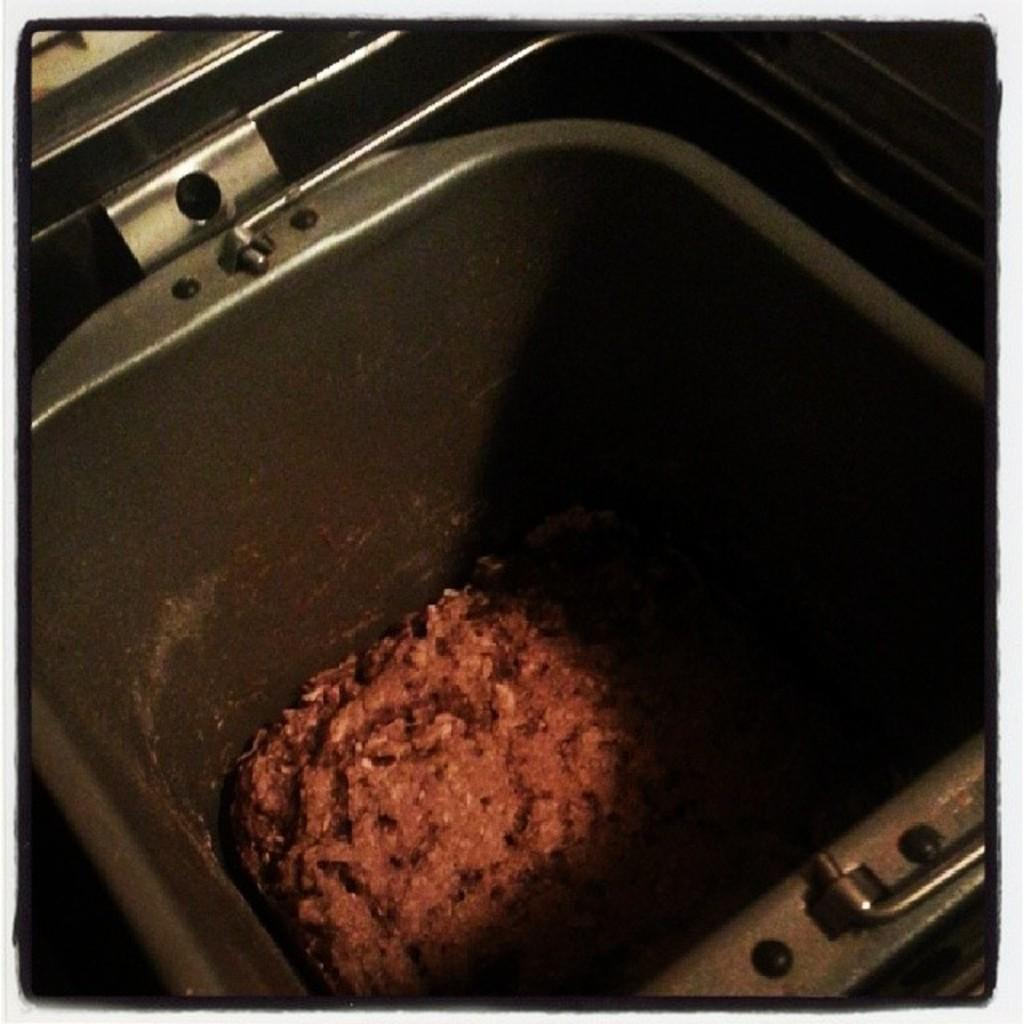What can be seen in the image? There is a container in the image. Can you describe the contents of the container? There is an object inside the container. How does the toad feel about being observed in the image? There is no toad present in the image, so it cannot be observed or have feelings about being observed. 